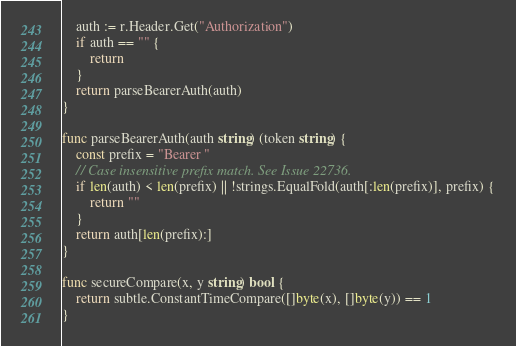<code> <loc_0><loc_0><loc_500><loc_500><_Go_>	auth := r.Header.Get("Authorization")
	if auth == "" {
		return
	}
	return parseBearerAuth(auth)
}

func parseBearerAuth(auth string) (token string) {
	const prefix = "Bearer "
	// Case insensitive prefix match. See Issue 22736.
	if len(auth) < len(prefix) || !strings.EqualFold(auth[:len(prefix)], prefix) {
		return ""
	}
	return auth[len(prefix):]
}

func secureCompare(x, y string) bool {
	return subtle.ConstantTimeCompare([]byte(x), []byte(y)) == 1
}
</code> 